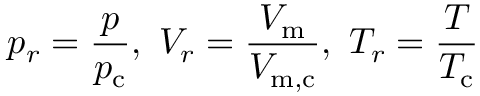<formula> <loc_0><loc_0><loc_500><loc_500>\ p _ { r } = { \frac { p } { p _ { c } } } , \ V _ { r } = { \frac { V _ { m } } { V _ { m , c } } } , \ T _ { r } = { \frac { T } { T _ { c } } }</formula> 